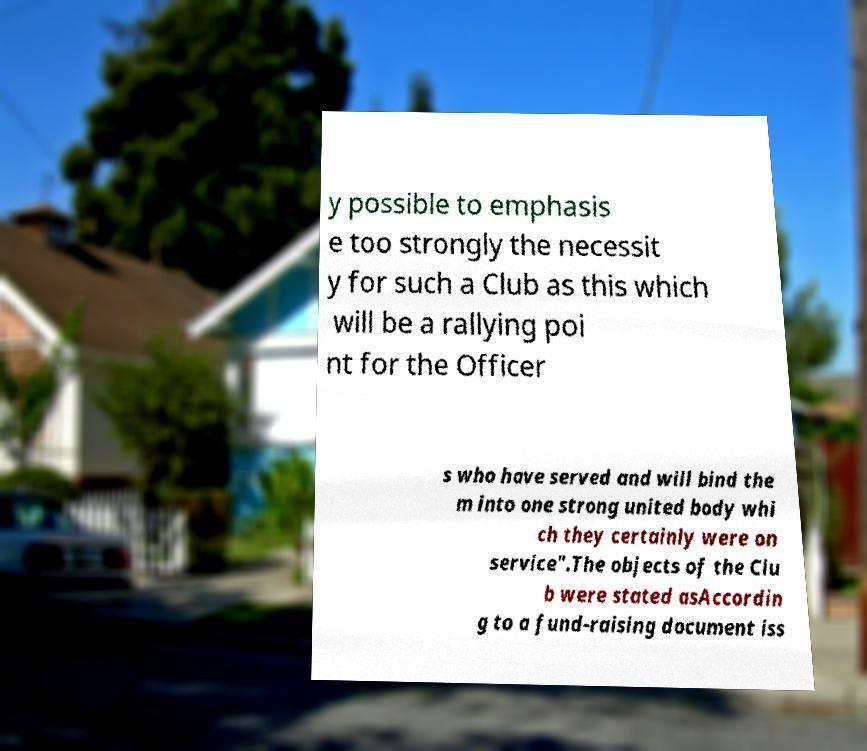Could you extract and type out the text from this image? y possible to emphasis e too strongly the necessit y for such a Club as this which will be a rallying poi nt for the Officer s who have served and will bind the m into one strong united body whi ch they certainly were on service".The objects of the Clu b were stated asAccordin g to a fund-raising document iss 